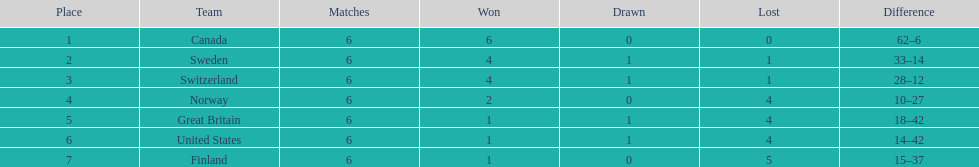How many teams won at least 4 matches? 3. Write the full table. {'header': ['Place', 'Team', 'Matches', 'Won', 'Drawn', 'Lost', 'Difference'], 'rows': [['1', 'Canada', '6', '6', '0', '0', '62–6'], ['2', 'Sweden', '6', '4', '1', '1', '33–14'], ['3', 'Switzerland', '6', '4', '1', '1', '28–12'], ['4', 'Norway', '6', '2', '0', '4', '10–27'], ['5', 'Great Britain', '6', '1', '1', '4', '18–42'], ['6', 'United States', '6', '1', '1', '4', '14–42'], ['7', 'Finland', '6', '1', '0', '5', '15–37']]} 